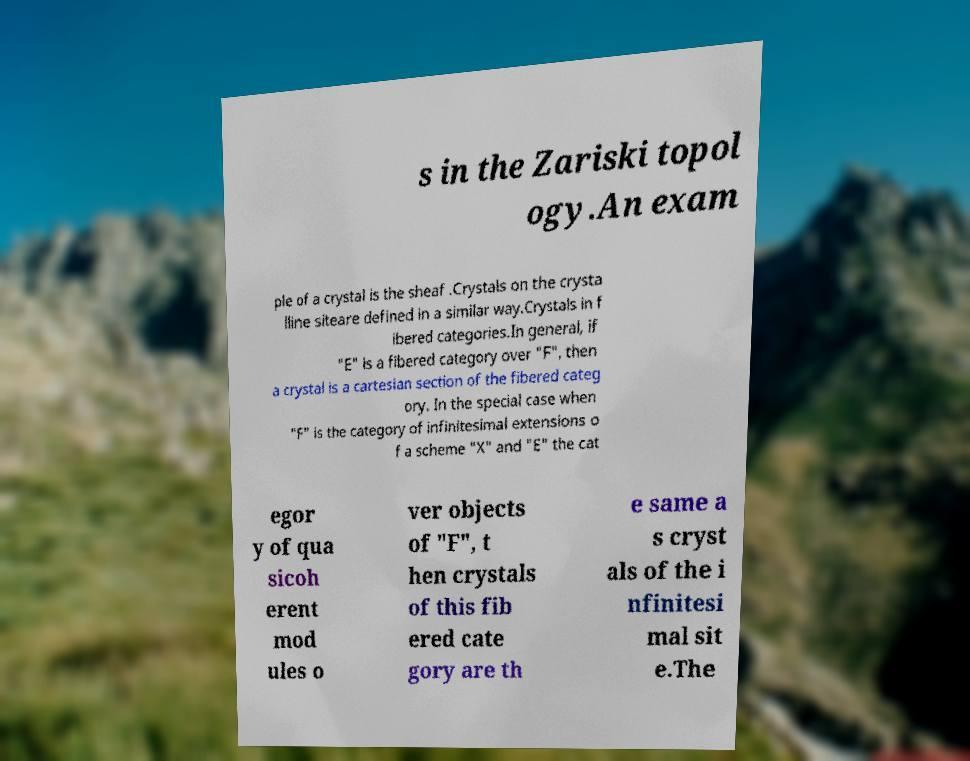For documentation purposes, I need the text within this image transcribed. Could you provide that? s in the Zariski topol ogy.An exam ple of a crystal is the sheaf .Crystals on the crysta lline siteare defined in a similar way.Crystals in f ibered categories.In general, if "E" is a fibered category over "F", then a crystal is a cartesian section of the fibered categ ory. In the special case when "F" is the category of infinitesimal extensions o f a scheme "X" and "E" the cat egor y of qua sicoh erent mod ules o ver objects of "F", t hen crystals of this fib ered cate gory are th e same a s cryst als of the i nfinitesi mal sit e.The 